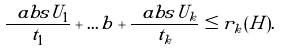<formula> <loc_0><loc_0><loc_500><loc_500>\frac { \ a b s { U _ { 1 } } } { t _ { 1 } } + \dots b + \frac { \ a b s { U _ { k } } } { t _ { k } } \leq r _ { k } ( H ) .</formula> 